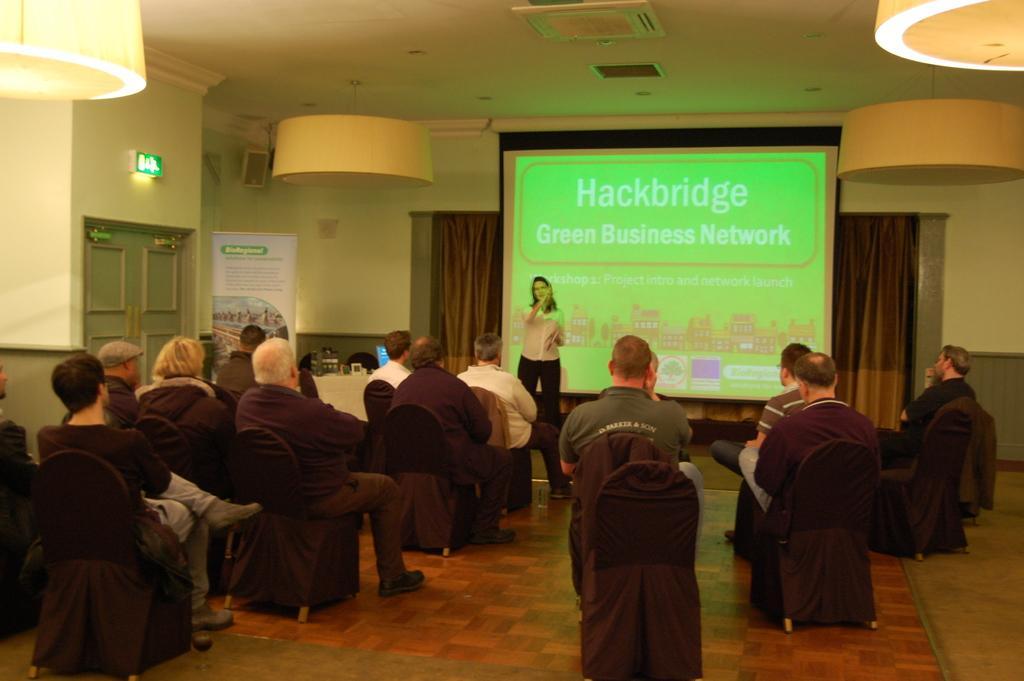Could you give a brief overview of what you see in this image? In this image we can see these people are sitting on the chairs. Here we can see this person is standing near the projector screen. In the background, we can see the door, banner, curtains, LED board and lights to the ceiling. 